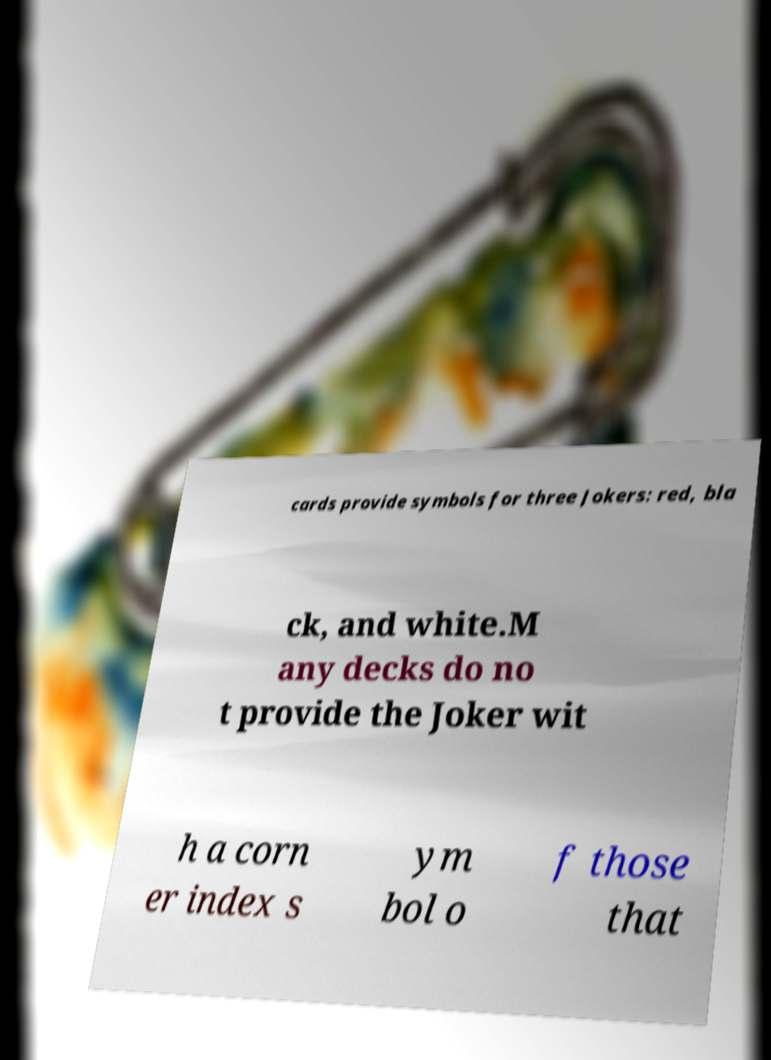Please read and relay the text visible in this image. What does it say? cards provide symbols for three Jokers: red, bla ck, and white.M any decks do no t provide the Joker wit h a corn er index s ym bol o f those that 